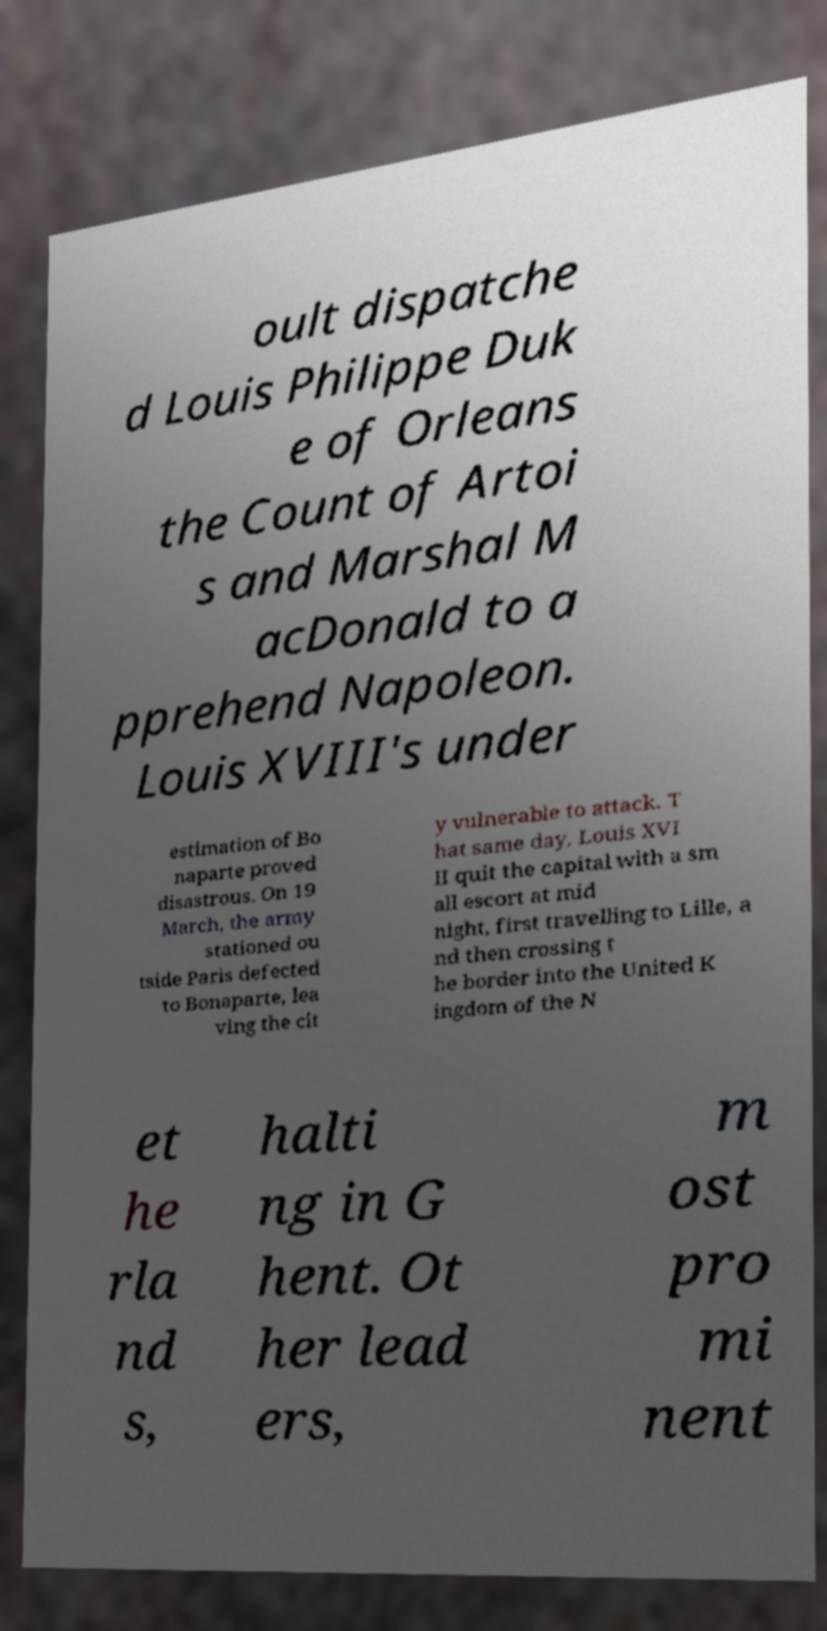Could you assist in decoding the text presented in this image and type it out clearly? oult dispatche d Louis Philippe Duk e of Orleans the Count of Artoi s and Marshal M acDonald to a pprehend Napoleon. Louis XVIII's under estimation of Bo naparte proved disastrous. On 19 March, the army stationed ou tside Paris defected to Bonaparte, lea ving the cit y vulnerable to attack. T hat same day, Louis XVI II quit the capital with a sm all escort at mid night, first travelling to Lille, a nd then crossing t he border into the United K ingdom of the N et he rla nd s, halti ng in G hent. Ot her lead ers, m ost pro mi nent 